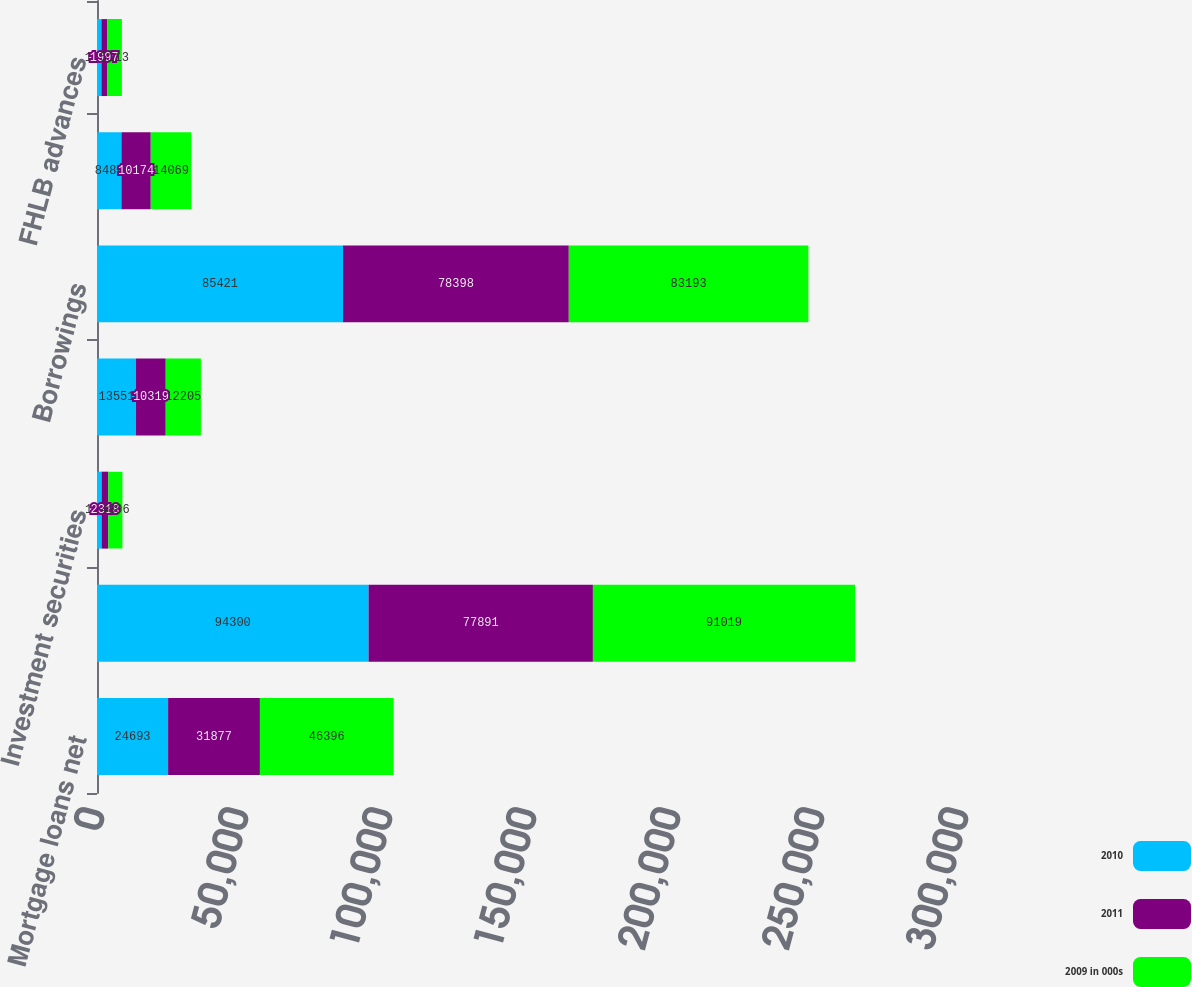Convert chart. <chart><loc_0><loc_0><loc_500><loc_500><stacked_bar_chart><ecel><fcel>Mortgage loans net<fcel>Emerald Advance lines of<fcel>Investment securities<fcel>Other<fcel>Borrowings<fcel>Deposits<fcel>FHLB advances<nl><fcel>2010<fcel>24693<fcel>94300<fcel>1609<fcel>13551<fcel>85421<fcel>8488<fcel>1526<nl><fcel>2011<fcel>31877<fcel>77891<fcel>2318<fcel>10319<fcel>78398<fcel>10174<fcel>1997<nl><fcel>2009 in 000s<fcel>46396<fcel>91019<fcel>4896<fcel>12205<fcel>83193<fcel>14069<fcel>5113<nl></chart> 